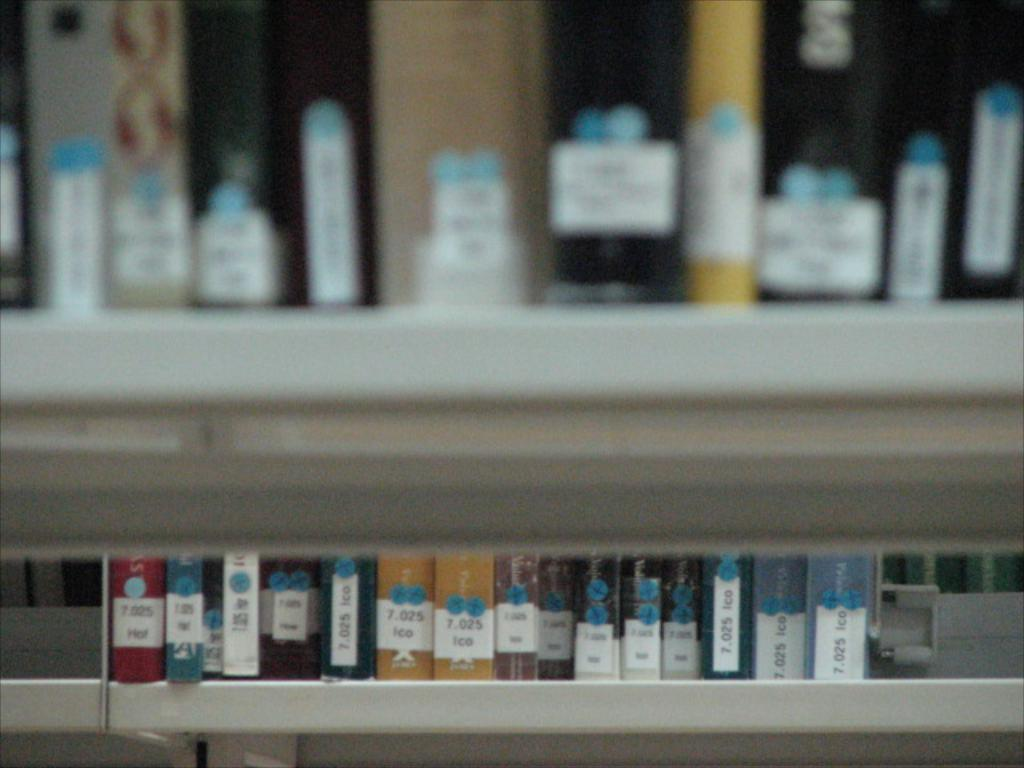What type of items can be seen in the image? There are many files and books in the image. How are the files and books organized in the image? The files and books are kept on racks. Where is the goldfish kept in the image? There is no goldfish present in the image. What type of container is used to hold the vase in the image? There is no vase present in the image. 